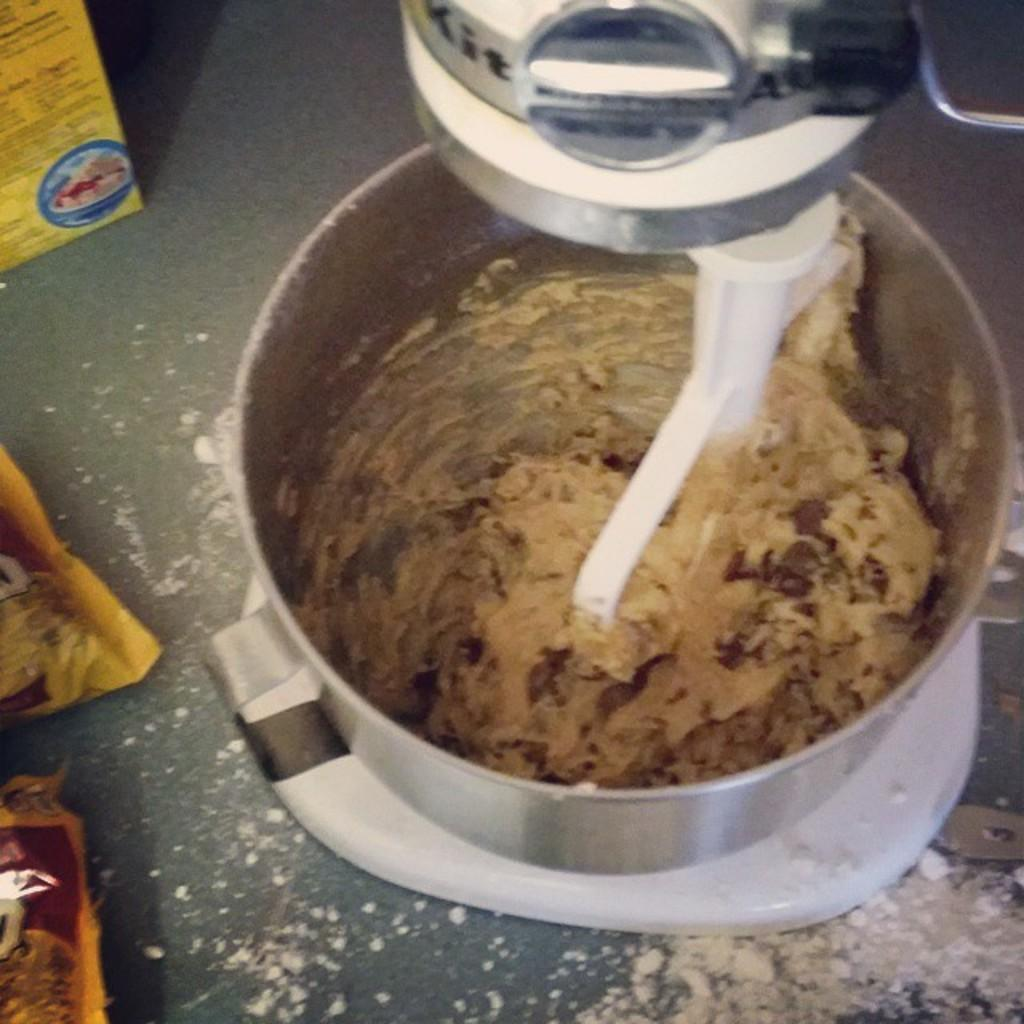What is the main object in the image? There is a grinder in the image. What can be seen on the right side of the image? There are yellow color packets on the right side of the image. What type of surface is visible in the background of the image? There is a floor visible in the background of the image. Is the grandfather sleeping with the chicken in the image? There is no grandfather or chicken present in the image. 